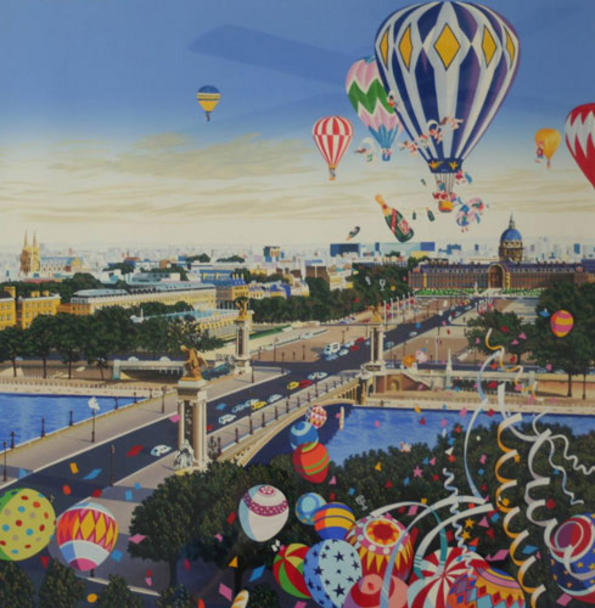Describe a short history of why the city has these hot air balloons. Make it realistic. The hot air balloons have become a hallmark of this city due to an annual festival that began decades ago. Originally, the festival was a small community gathering to celebrate the invention of the hot air balloon by a renowned scientist who lived in the city. Over time, the festival grew in popularity, attracting visitors from near and far, and the balloons themselves became more elaborate and artistic. Today, the festival is a grand event, celebrated with great enthusiasm, and the balloons are a tribute to the city's innovative spirit and heritage. 